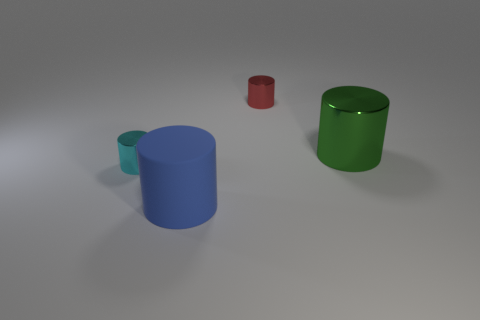Is there any other thing of the same color as the big matte thing?
Offer a very short reply. No. How many big green matte cylinders are there?
Give a very brief answer. 0. There is a big green cylinder right of the cyan cylinder that is behind the blue cylinder; what is it made of?
Ensure brevity in your answer.  Metal. There is a cylinder on the right side of the tiny metallic thing behind the metal thing in front of the green metal thing; what is its color?
Your response must be concise. Green. Do the big metal object and the big rubber cylinder have the same color?
Your answer should be very brief. No. How many red cylinders have the same size as the green cylinder?
Give a very brief answer. 0. Are there more big things to the left of the large blue thing than metallic things right of the large metallic cylinder?
Your answer should be compact. No. There is a big object to the right of the large thing in front of the cyan thing; what is its color?
Give a very brief answer. Green. Is the material of the big blue cylinder the same as the green cylinder?
Your answer should be compact. No. Are there any tiny red shiny things of the same shape as the cyan thing?
Your answer should be compact. Yes. 